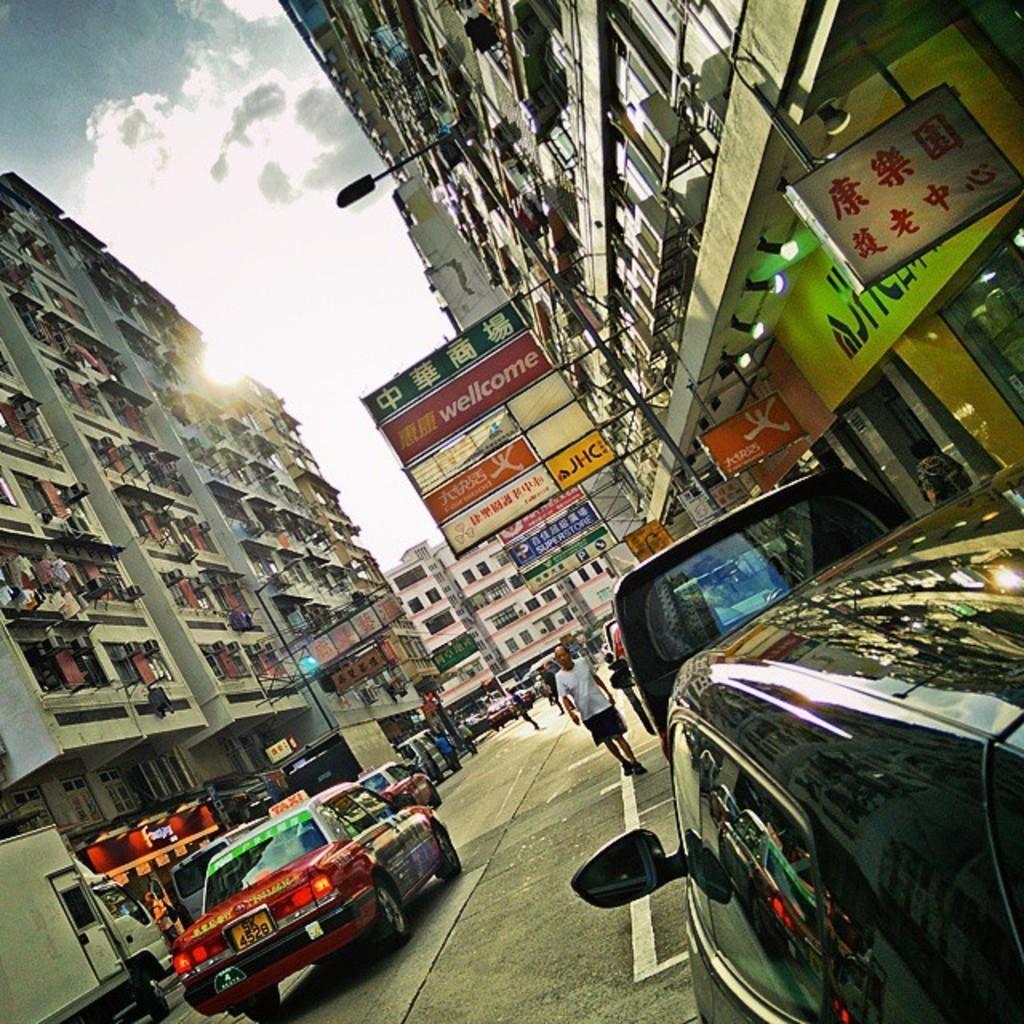Describe this image in one or two sentences. In this picture we can observe some cars on the road. There are some people walking. We can observe buildings and some boards fixed to the pole. In the background there is a sky with some clouds. 